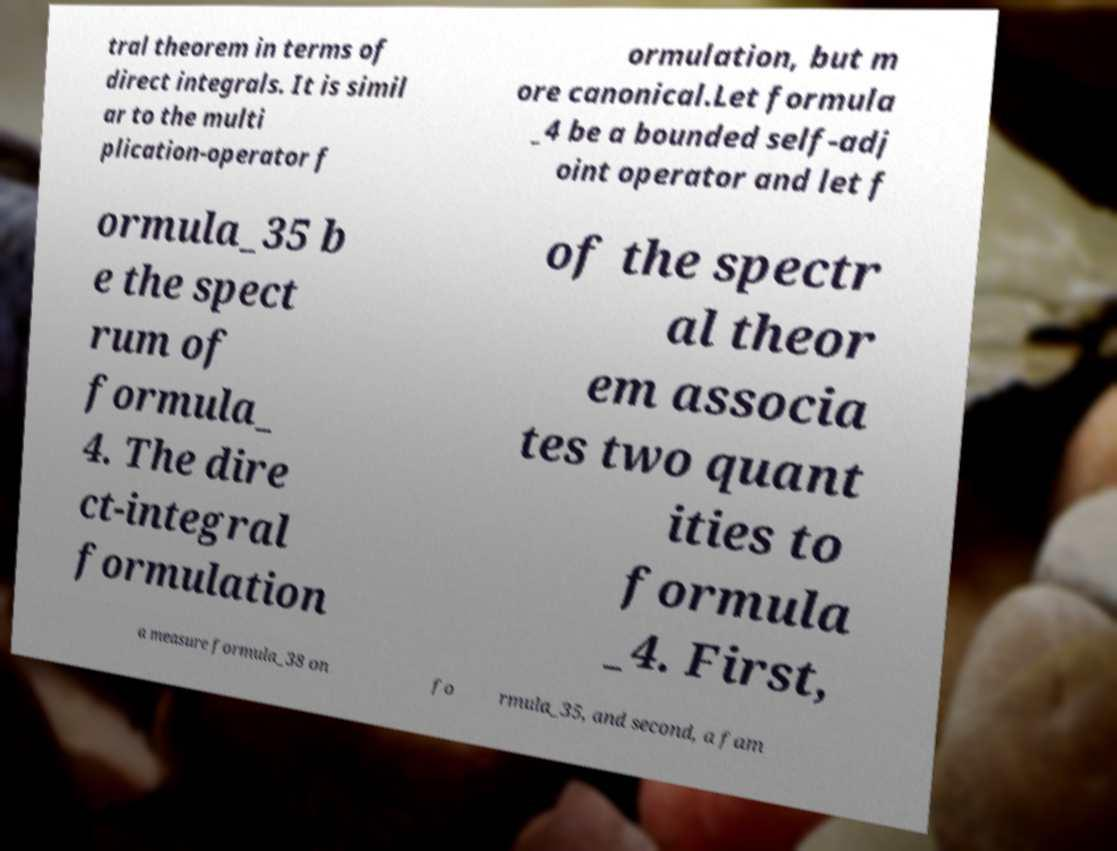Can you accurately transcribe the text from the provided image for me? tral theorem in terms of direct integrals. It is simil ar to the multi plication-operator f ormulation, but m ore canonical.Let formula _4 be a bounded self-adj oint operator and let f ormula_35 b e the spect rum of formula_ 4. The dire ct-integral formulation of the spectr al theor em associa tes two quant ities to formula _4. First, a measure formula_38 on fo rmula_35, and second, a fam 